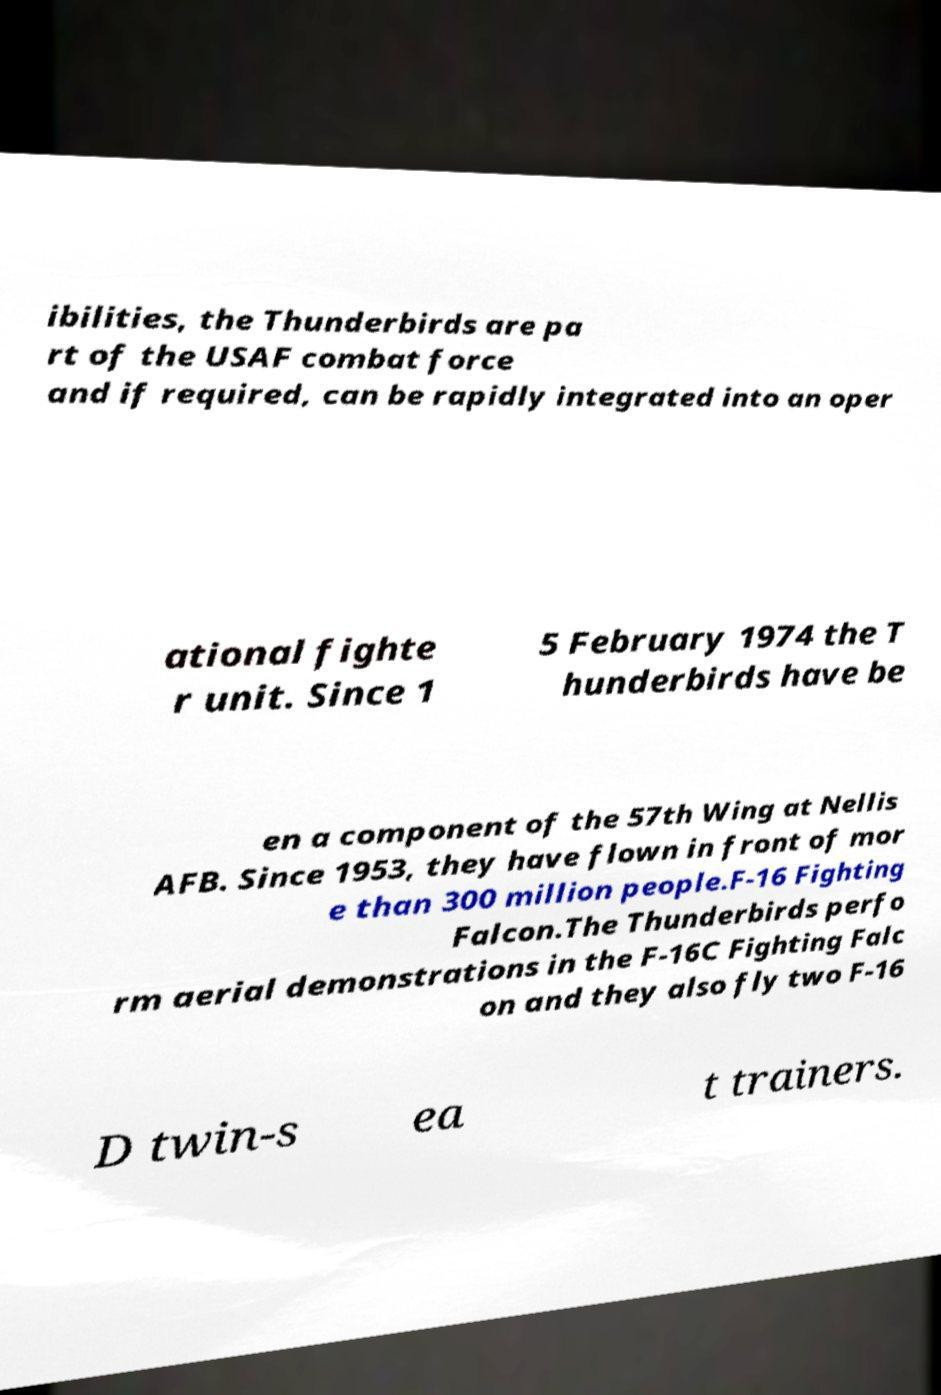Please read and relay the text visible in this image. What does it say? ibilities, the Thunderbirds are pa rt of the USAF combat force and if required, can be rapidly integrated into an oper ational fighte r unit. Since 1 5 February 1974 the T hunderbirds have be en a component of the 57th Wing at Nellis AFB. Since 1953, they have flown in front of mor e than 300 million people.F-16 Fighting Falcon.The Thunderbirds perfo rm aerial demonstrations in the F-16C Fighting Falc on and they also fly two F-16 D twin-s ea t trainers. 